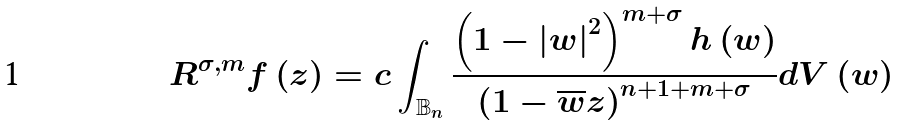Convert formula to latex. <formula><loc_0><loc_0><loc_500><loc_500>R ^ { \sigma , m } f \left ( z \right ) = c \int _ { \mathbb { B } _ { n } } \frac { \left ( 1 - \left | w \right | ^ { 2 } \right ) ^ { m + \sigma } h \left ( w \right ) } { \left ( 1 - \overline { w } z \right ) ^ { n + 1 + m + \sigma } } d V \left ( w \right )</formula> 